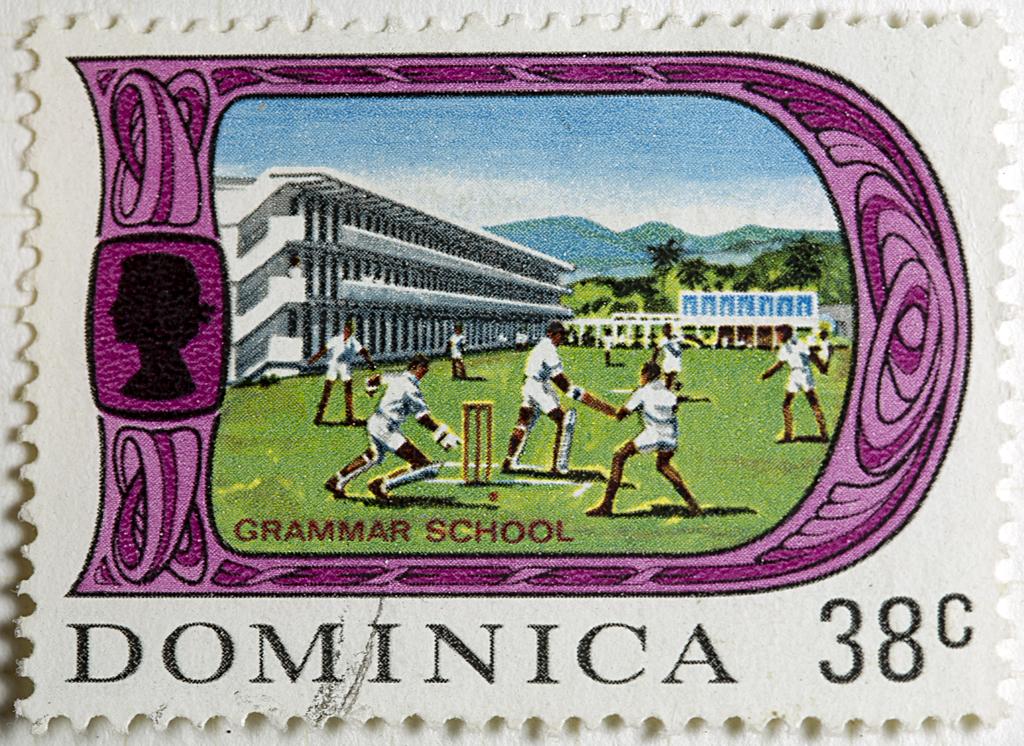What is the value of the stamp?
Provide a succinct answer. 38c. What is the stamp representing?
Make the answer very short. Grammar school. 